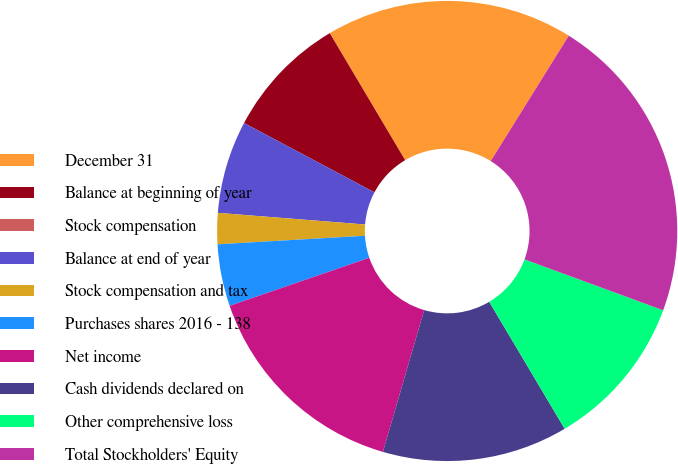<chart> <loc_0><loc_0><loc_500><loc_500><pie_chart><fcel>December 31<fcel>Balance at beginning of year<fcel>Stock compensation<fcel>Balance at end of year<fcel>Stock compensation and tax<fcel>Purchases shares 2016 - 138<fcel>Net income<fcel>Cash dividends declared on<fcel>Other comprehensive loss<fcel>Total Stockholders' Equity<nl><fcel>17.39%<fcel>8.7%<fcel>0.0%<fcel>6.52%<fcel>2.18%<fcel>4.35%<fcel>15.22%<fcel>13.04%<fcel>10.87%<fcel>21.74%<nl></chart> 